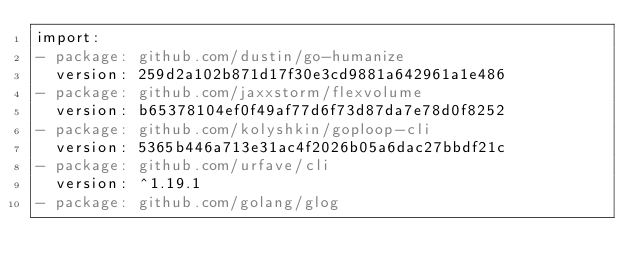Convert code to text. <code><loc_0><loc_0><loc_500><loc_500><_YAML_>import:
- package: github.com/dustin/go-humanize
  version: 259d2a102b871d17f30e3cd9881a642961a1e486
- package: github.com/jaxxstorm/flexvolume
  version: b65378104ef0f49af77d6f73d87da7e78d0f8252
- package: github.com/kolyshkin/goploop-cli
  version: 5365b446a713e31ac4f2026b05a6dac27bbdf21c
- package: github.com/urfave/cli
  version: ^1.19.1
- package: github.com/golang/glog
</code> 